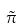<formula> <loc_0><loc_0><loc_500><loc_500>\tilde { \pi }</formula> 